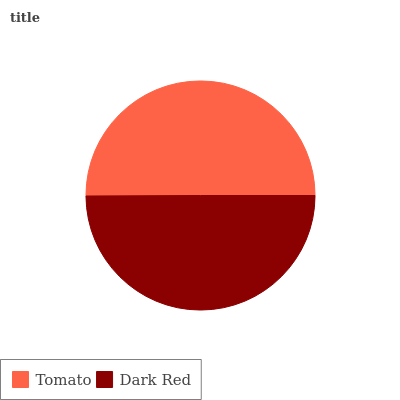Is Dark Red the minimum?
Answer yes or no. Yes. Is Tomato the maximum?
Answer yes or no. Yes. Is Dark Red the maximum?
Answer yes or no. No. Is Tomato greater than Dark Red?
Answer yes or no. Yes. Is Dark Red less than Tomato?
Answer yes or no. Yes. Is Dark Red greater than Tomato?
Answer yes or no. No. Is Tomato less than Dark Red?
Answer yes or no. No. Is Tomato the high median?
Answer yes or no. Yes. Is Dark Red the low median?
Answer yes or no. Yes. Is Dark Red the high median?
Answer yes or no. No. Is Tomato the low median?
Answer yes or no. No. 